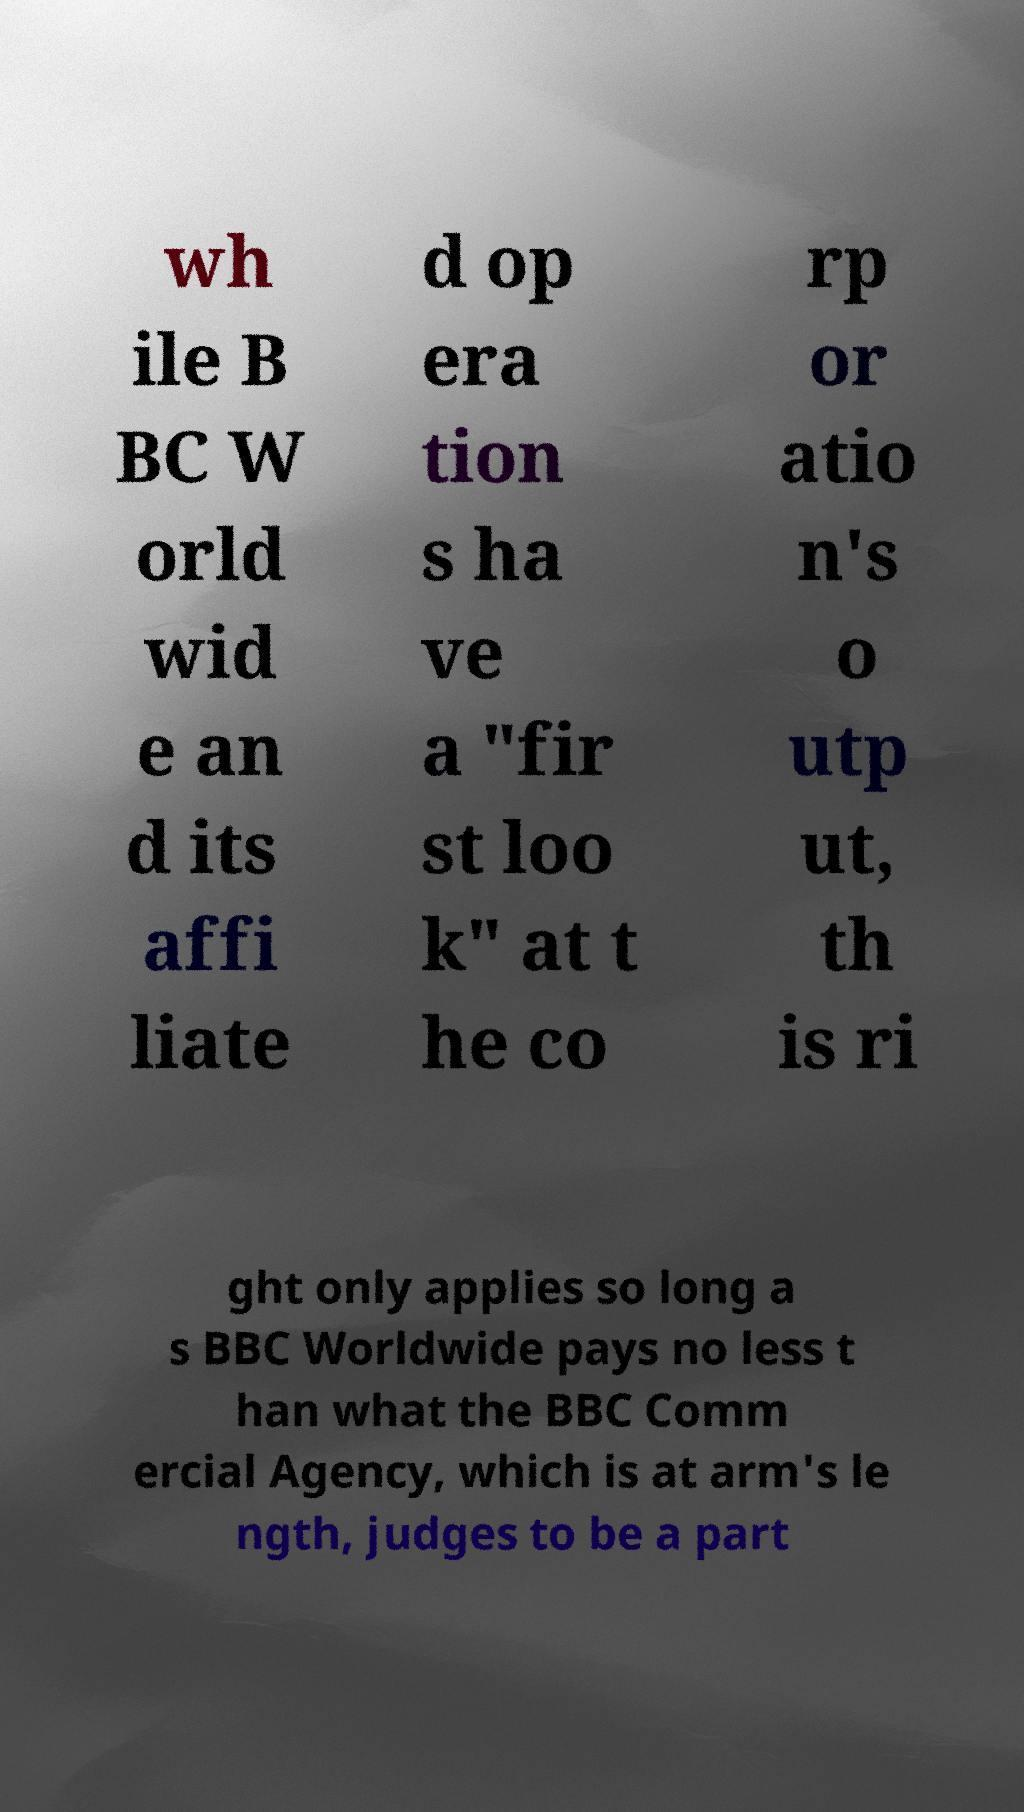Can you accurately transcribe the text from the provided image for me? wh ile B BC W orld wid e an d its affi liate d op era tion s ha ve a "fir st loo k" at t he co rp or atio n's o utp ut, th is ri ght only applies so long a s BBC Worldwide pays no less t han what the BBC Comm ercial Agency, which is at arm's le ngth, judges to be a part 